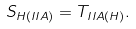Convert formula to latex. <formula><loc_0><loc_0><loc_500><loc_500>S _ { H ( I I A ) } = T _ { I I A ( H ) } .</formula> 